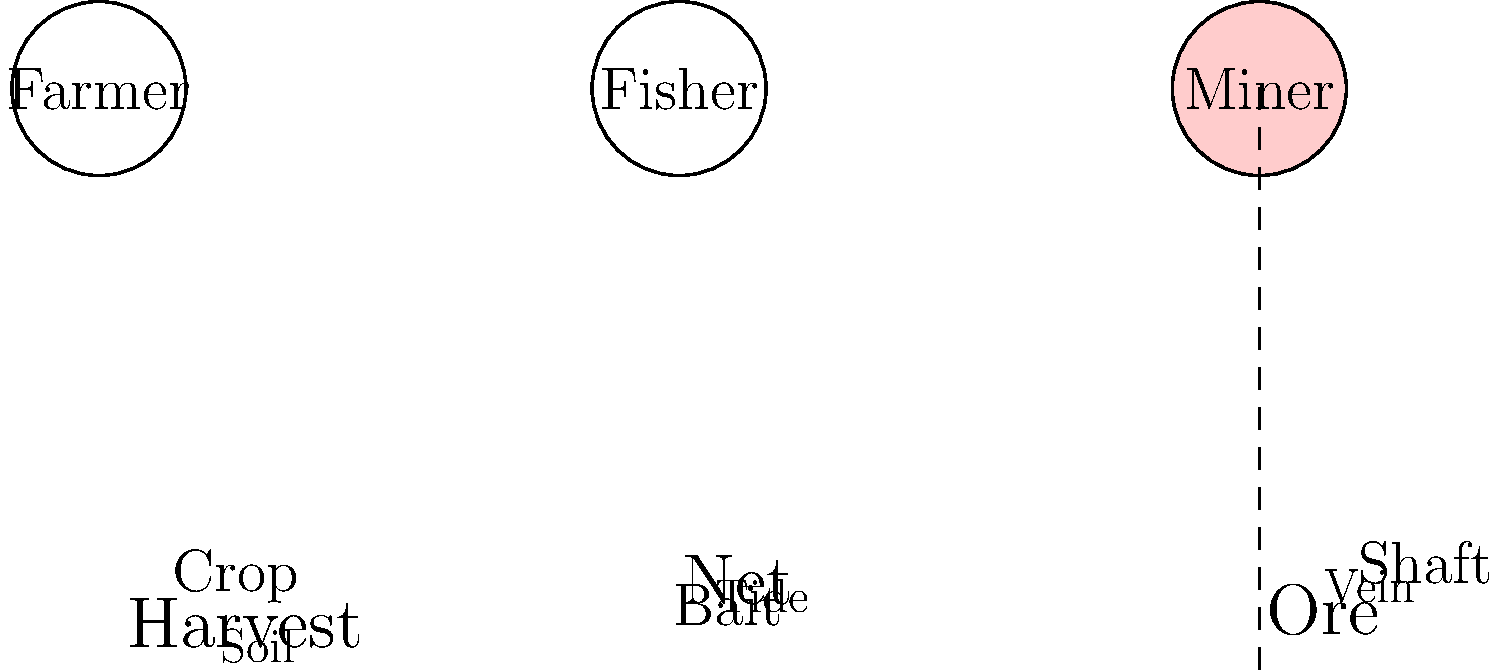Based on the pictograms and word clouds shown, which traditional occupation appears to have the most specialized vocabulary related to geological features, and how might this reflect the cultural significance of the profession in certain communities? 1. Analyze the pictograms:
   - Three traditional occupations are represented: Farmer, Fisher, and Miner.
   - The Miner pictogram is highlighted, suggesting it's the focus of our attention.

2. Examine the word clouds:
   - Farmer: "Harvest," "Crop," "Soil" - agricultural terms
   - Fisher: "Net," "Bait," "Tide" - fishing-related terms
   - Miner: "Ore," "Shaft," "Vein" - geological and mining terms

3. Compare the vocabulary:
   - The Miner's word cloud contains terms directly related to geological features (e.g., "Vein," "Ore").
   - These terms are more specialized and specific to the geological aspects of mining.

4. Cultural significance:
   - The specialized vocabulary suggests that mining has developed a unique linguistic subset.
   - This specialized language likely evolved due to the technical nature of the work and the need for precise communication about geological formations.

5. Community impact:
   - Communities where mining is a primary occupation would likely have this specialized vocabulary integrated into their daily language.
   - The prevalence of these terms could indicate the importance of mining in the local culture and economy.

6. Linguistic anthropology perspective:
   - The development of this specialized vocabulary demonstrates how occupational needs shape language.
   - It also shows how social and cultural factors (in this case, the mining profession) influence linguistic evolution within a community.
Answer: Mining; reflects technical nature and cultural importance of the profession 